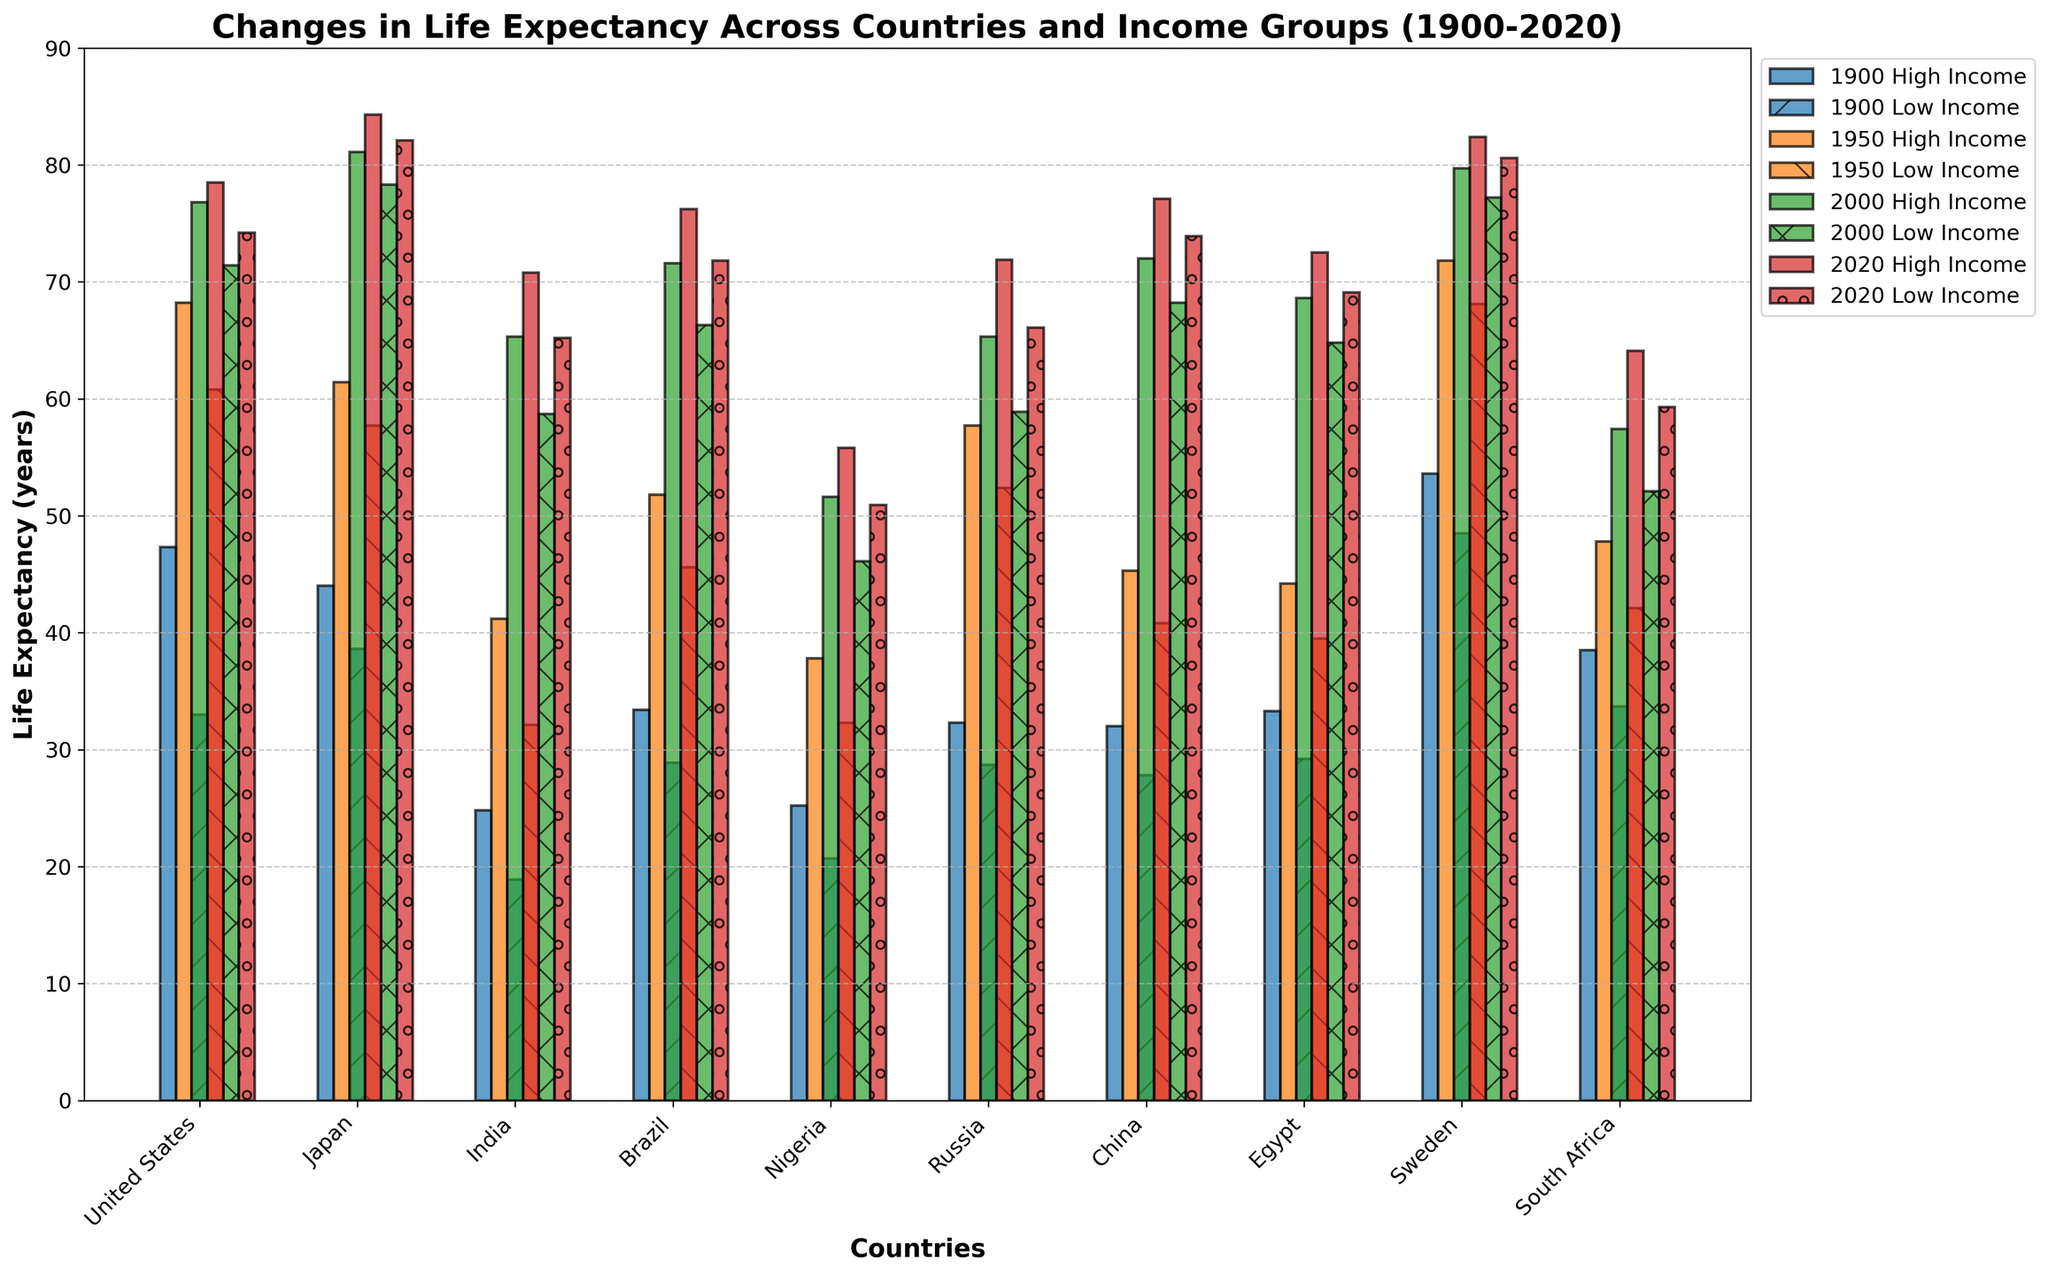How did the life expectancy in Japan for high-income groups change from 1900 to 2020? In 1900, the life expectancy for high-income groups in Japan was 44.0 years. By 2020, it increased to 84.3 years. The change is calculated by subtracting the 1900 value from the 2020 value (84.3 - 44.0).
Answer: 40.3 years Which country had the highest life expectancy in 2020 for high-income groups, and what was it? By examining the heights of the bars corresponding to high-income groups in 2020, Japan had the highest life expectancy at 84.3 years.
Answer: Japan, 84.3 years What was the difference in life expectancy between high-income and low-income groups in Nigeria in 2020? For Nigeria in 2020, the life expectancy of high-income groups was 55.8 years, while it was 50.9 years for low-income groups. The difference is calculated as 55.8 - 50.9.
Answer: 4.9 years How does the life expectancy of low-income groups in China in 2000 compare to that of high-income groups in the United States in 2000? In 2000, the life expectancy of low-income groups in China was 68.2 years, while for high-income groups in the United States, it was 76.8 years. Comparing these values shows that the high-income group in the US had a higher life expectancy in 2000.
Answer: US high-income was higher By how many years did the life expectancy for high-income groups in Russia increase from 1950 to 2020? In 1950, the life expectancy for high-income groups in Russia was 57.7 years. By 2020, it increased to 71.9 years. The change is calculated by subtracting the 1950 value from the 2020 value (71.9 - 57.7).
Answer: 14.2 years Which country saw the smallest increase in life expectancy for low-income groups from 1900 to 2020? By examining the bar heights, Nigeria saw the smallest increase in life expectancy for low-income groups from 20.7 years in 1900 to 50.9 years in 2020, a change of 30.2 years.
Answer: Nigeria Compare the life expectancy for high-income and low-income groups in India in 2020. Which group has a higher expectancy and by how much? In India in 2020, the life expectancy for high-income groups was 70.8 years, while for low-income groups, it was 65.2 years. The high-income group had a higher life expectancy by 70.8 - 65.2 years.
Answer: High-income by 5.6 years What was the average life expectancy of low-income groups across all countries in 2020? Add the life expectancies of low-income groups for all countries in 2020 and divide by the number of countries: (74.2 + 82.1 + 65.2 + 71.8 + 50.9 + 66.1 + 73.9 + 69.1 + 80.6 + 59.3) / 10.
Answer: 69.32 years 